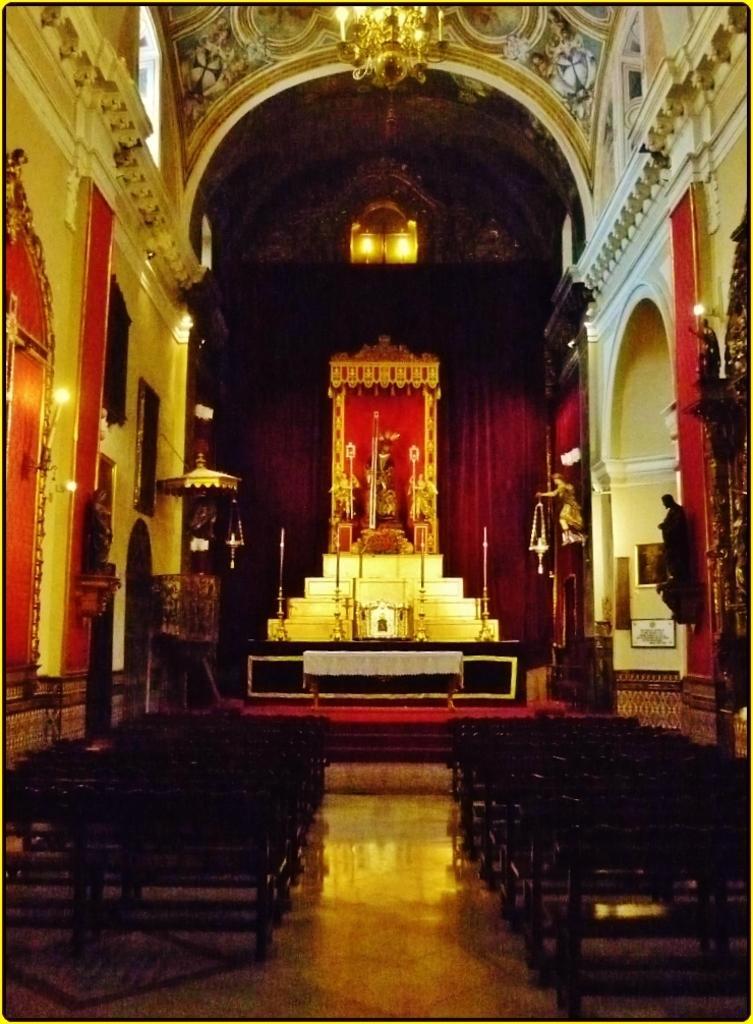In one or two sentences, can you explain what this image depicts? In this picture we can see an inside view of a church, there are some benches in the front, in the background we can see a statue, an umbrella and curtain, there are two lights and a chandelier at the top of the picture. 